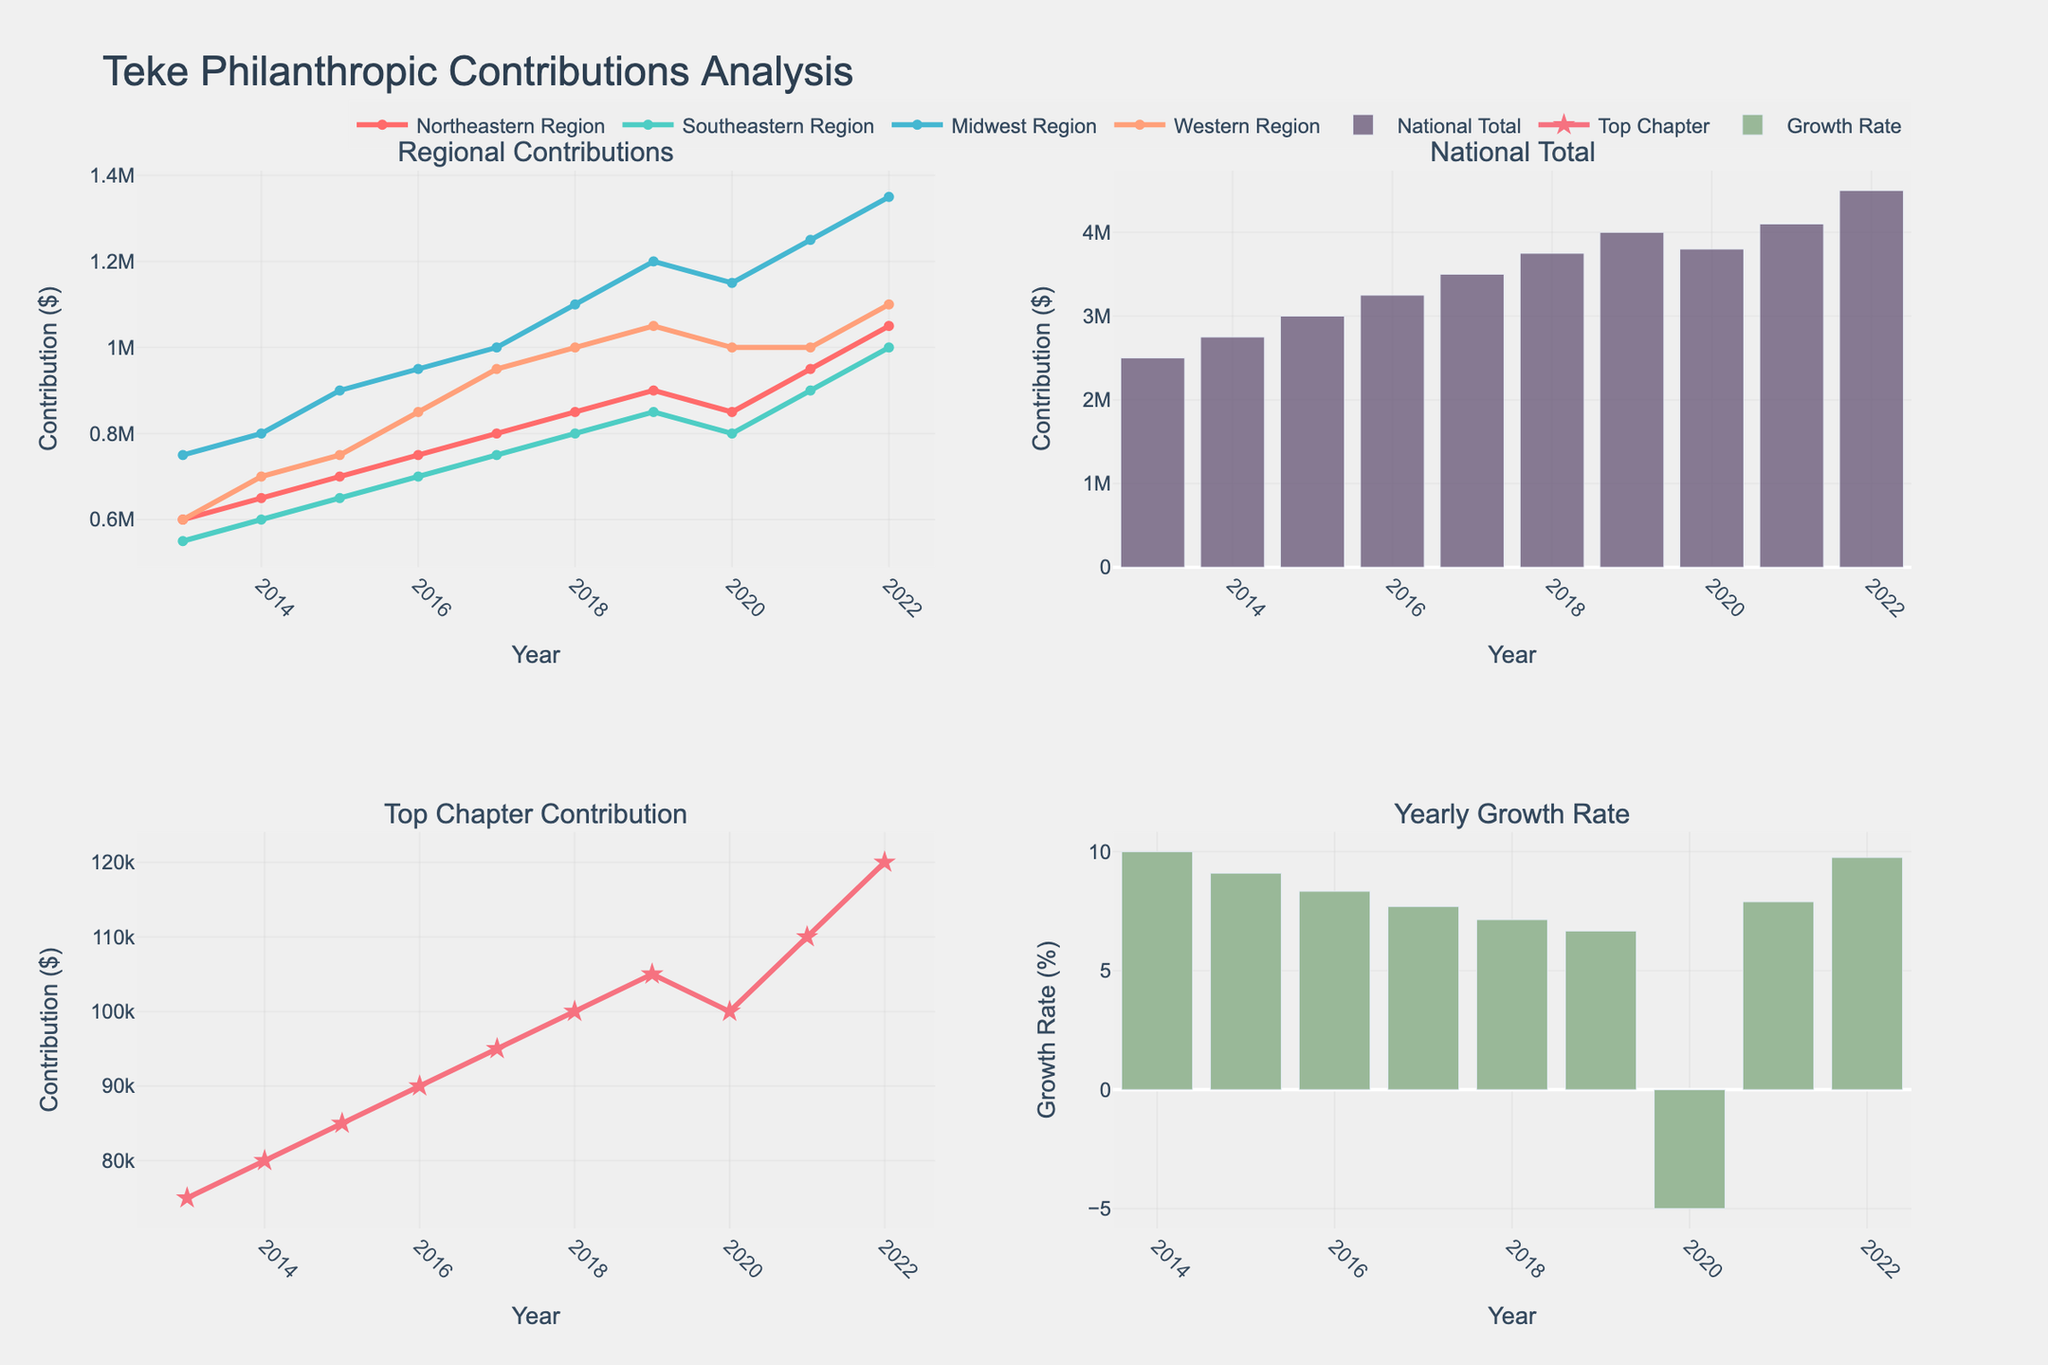What is the title of the figure? The title is located at the top of the figure and is prominently displayed.
Answer: Teke Philanthropic Contributions Analysis How many subplots are there in the figure? The figure is divided into segments; counting these divisions will give the total number of subplots.
Answer: 4 Which region had the highest contribution in 2022? Look at the lines in the Regional Contributions subplot for 2022 and identify the highest point.
Answer: Western Region What is the National Total contribution in 2017? Refer to the bar heights in the National Total subplot for the year 2017.
Answer: $3,500,000 Did the National Total contribution increase or decrease from 2019 to 2020? Compare the heights of the bars for 2019 and 2020 in the National Total subplot.
Answer: Decrease Which year registered a negative growth rate? Look at the bars in the Yearly Growth Rate subplot and find any bar that extends below zero.
Answer: 2020 What was the growth rate in 2021? Check the Yearly Growth Rate subplot and refer to the bar for the year 2021.
Answer: ≈7.9% Which subplot includes both lines and markers? The presence of markers along with lines can be identified visually in one of the subplots.
Answer: Top Chapter Contribution Does the Southeastern Region always contribute more than the Northeastern Region? Compare the lines representing these two regions across all the years in the Regional Contributions subplot.
Answer: No What is the average Top Chapter contribution from 2013 to 2022? Sum all the values for Top Chapter Contribution and divide by the total number of years.
Answer: $92,000 